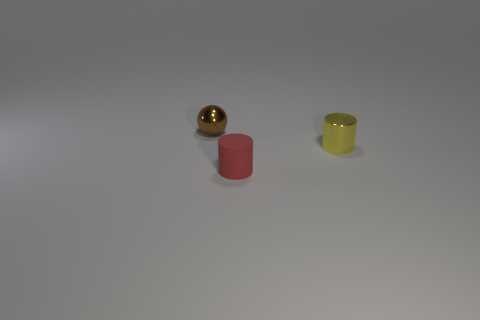Add 2 small rubber objects. How many objects exist? 5 Subtract all balls. How many objects are left? 2 Subtract all small matte things. Subtract all matte blocks. How many objects are left? 2 Add 3 tiny brown objects. How many tiny brown objects are left? 4 Add 2 purple matte objects. How many purple matte objects exist? 2 Subtract 0 yellow cubes. How many objects are left? 3 